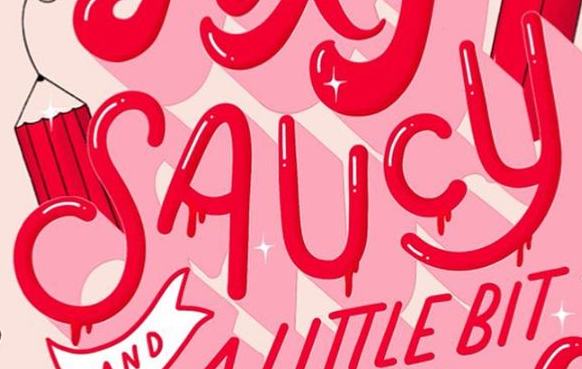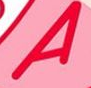What text is displayed in these images sequentially, separated by a semicolon? SAUCY; A 